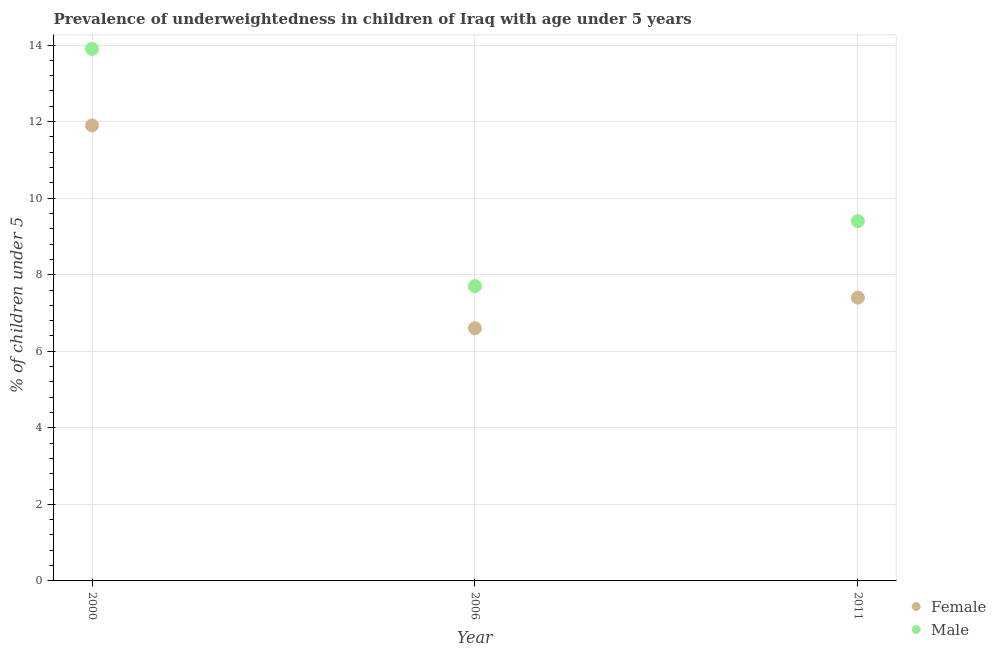What is the percentage of underweighted male children in 2011?
Provide a succinct answer. 9.4. Across all years, what is the maximum percentage of underweighted male children?
Ensure brevity in your answer.  13.9. Across all years, what is the minimum percentage of underweighted male children?
Your answer should be compact. 7.7. In which year was the percentage of underweighted male children maximum?
Your response must be concise. 2000. What is the total percentage of underweighted male children in the graph?
Ensure brevity in your answer.  31. What is the difference between the percentage of underweighted male children in 2000 and that in 2011?
Offer a terse response. 4.5. What is the difference between the percentage of underweighted female children in 2006 and the percentage of underweighted male children in 2000?
Keep it short and to the point. -7.3. What is the average percentage of underweighted male children per year?
Provide a succinct answer. 10.33. In the year 2006, what is the difference between the percentage of underweighted male children and percentage of underweighted female children?
Offer a very short reply. 1.1. What is the ratio of the percentage of underweighted female children in 2006 to that in 2011?
Ensure brevity in your answer.  0.89. Is the percentage of underweighted female children in 2000 less than that in 2006?
Keep it short and to the point. No. Is the difference between the percentage of underweighted female children in 2000 and 2011 greater than the difference between the percentage of underweighted male children in 2000 and 2011?
Provide a succinct answer. No. What is the difference between the highest and the second highest percentage of underweighted male children?
Offer a terse response. 4.5. What is the difference between the highest and the lowest percentage of underweighted male children?
Give a very brief answer. 6.2. How many dotlines are there?
Keep it short and to the point. 2. How many years are there in the graph?
Your answer should be very brief. 3. Are the values on the major ticks of Y-axis written in scientific E-notation?
Keep it short and to the point. No. Does the graph contain any zero values?
Your response must be concise. No. Where does the legend appear in the graph?
Provide a succinct answer. Bottom right. How are the legend labels stacked?
Give a very brief answer. Vertical. What is the title of the graph?
Give a very brief answer. Prevalence of underweightedness in children of Iraq with age under 5 years. Does "IMF concessional" appear as one of the legend labels in the graph?
Your answer should be compact. No. What is the label or title of the X-axis?
Offer a terse response. Year. What is the label or title of the Y-axis?
Provide a succinct answer.  % of children under 5. What is the  % of children under 5 of Female in 2000?
Your response must be concise. 11.9. What is the  % of children under 5 of Male in 2000?
Keep it short and to the point. 13.9. What is the  % of children under 5 of Female in 2006?
Provide a short and direct response. 6.6. What is the  % of children under 5 of Male in 2006?
Your response must be concise. 7.7. What is the  % of children under 5 in Female in 2011?
Make the answer very short. 7.4. What is the  % of children under 5 of Male in 2011?
Keep it short and to the point. 9.4. Across all years, what is the maximum  % of children under 5 of Female?
Ensure brevity in your answer.  11.9. Across all years, what is the maximum  % of children under 5 of Male?
Your answer should be compact. 13.9. Across all years, what is the minimum  % of children under 5 of Female?
Ensure brevity in your answer.  6.6. Across all years, what is the minimum  % of children under 5 in Male?
Ensure brevity in your answer.  7.7. What is the total  % of children under 5 in Female in the graph?
Ensure brevity in your answer.  25.9. What is the difference between the  % of children under 5 of Male in 2000 and that in 2006?
Your answer should be very brief. 6.2. What is the average  % of children under 5 of Female per year?
Make the answer very short. 8.63. What is the average  % of children under 5 in Male per year?
Provide a short and direct response. 10.33. In the year 2000, what is the difference between the  % of children under 5 in Female and  % of children under 5 in Male?
Ensure brevity in your answer.  -2. In the year 2006, what is the difference between the  % of children under 5 in Female and  % of children under 5 in Male?
Provide a short and direct response. -1.1. In the year 2011, what is the difference between the  % of children under 5 of Female and  % of children under 5 of Male?
Provide a short and direct response. -2. What is the ratio of the  % of children under 5 in Female in 2000 to that in 2006?
Your response must be concise. 1.8. What is the ratio of the  % of children under 5 in Male in 2000 to that in 2006?
Your answer should be very brief. 1.81. What is the ratio of the  % of children under 5 in Female in 2000 to that in 2011?
Your response must be concise. 1.61. What is the ratio of the  % of children under 5 in Male in 2000 to that in 2011?
Ensure brevity in your answer.  1.48. What is the ratio of the  % of children under 5 in Female in 2006 to that in 2011?
Your answer should be compact. 0.89. What is the ratio of the  % of children under 5 in Male in 2006 to that in 2011?
Give a very brief answer. 0.82. What is the difference between the highest and the second highest  % of children under 5 of Female?
Provide a succinct answer. 4.5. What is the difference between the highest and the second highest  % of children under 5 of Male?
Ensure brevity in your answer.  4.5. What is the difference between the highest and the lowest  % of children under 5 of Male?
Your answer should be very brief. 6.2. 